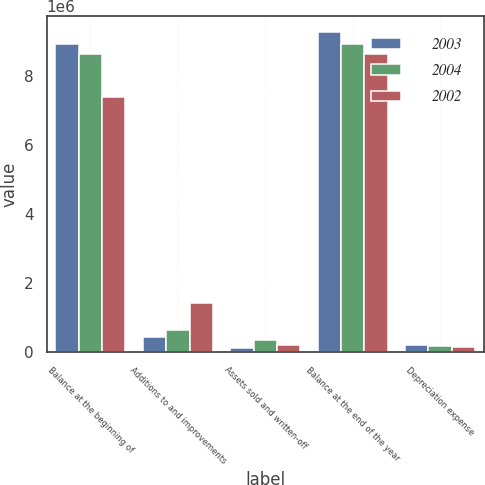Convert chart. <chart><loc_0><loc_0><loc_500><loc_500><stacked_bar_chart><ecel><fcel>Balance at the beginning of<fcel>Additions to and improvements<fcel>Assets sold and written-off<fcel>Balance at the end of the year<fcel>Depreciation expense<nl><fcel>2003<fcel>8.91779e+06<fcel>454806<fcel>115955<fcel>9.25664e+06<fcel>222142<nl><fcel>2004<fcel>8.6207e+06<fcel>647977<fcel>350888<fcel>8.91779e+06<fcel>186886<nl><fcel>2002<fcel>7.39137e+06<fcel>1.42603e+06<fcel>196695<fcel>8.6207e+06<fcel>164063<nl></chart> 